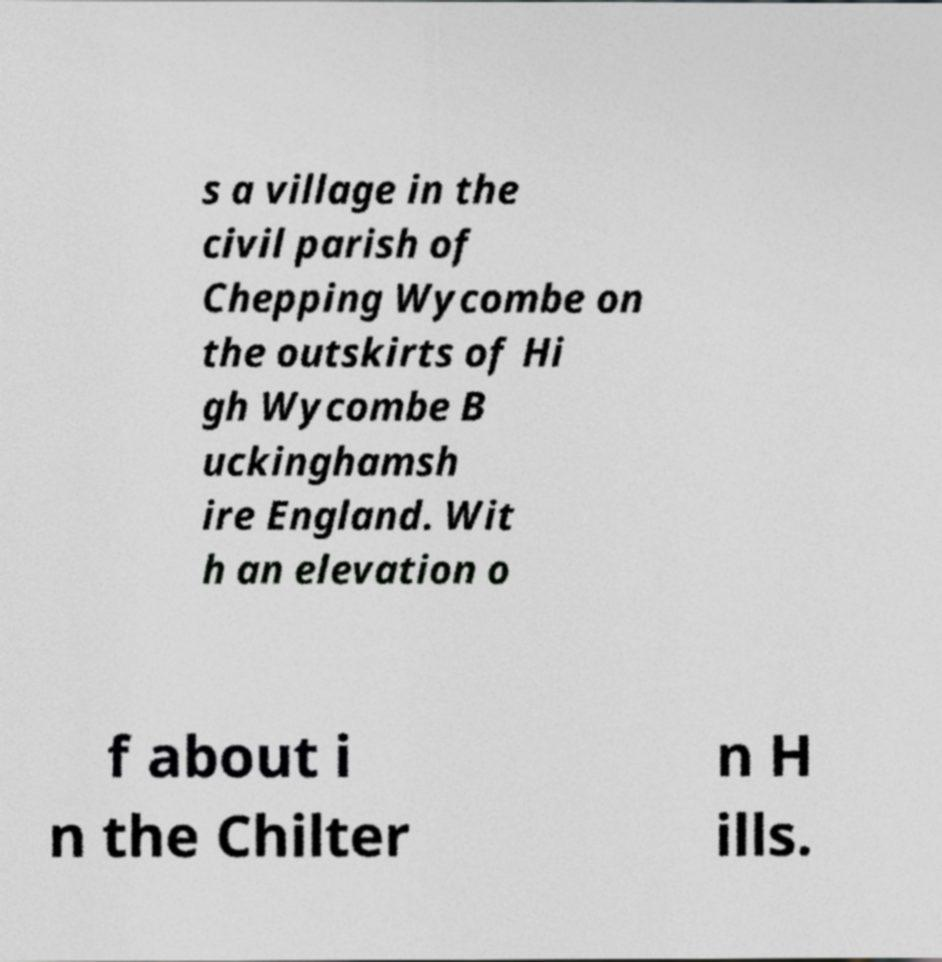Could you extract and type out the text from this image? s a village in the civil parish of Chepping Wycombe on the outskirts of Hi gh Wycombe B uckinghamsh ire England. Wit h an elevation o f about i n the Chilter n H ills. 